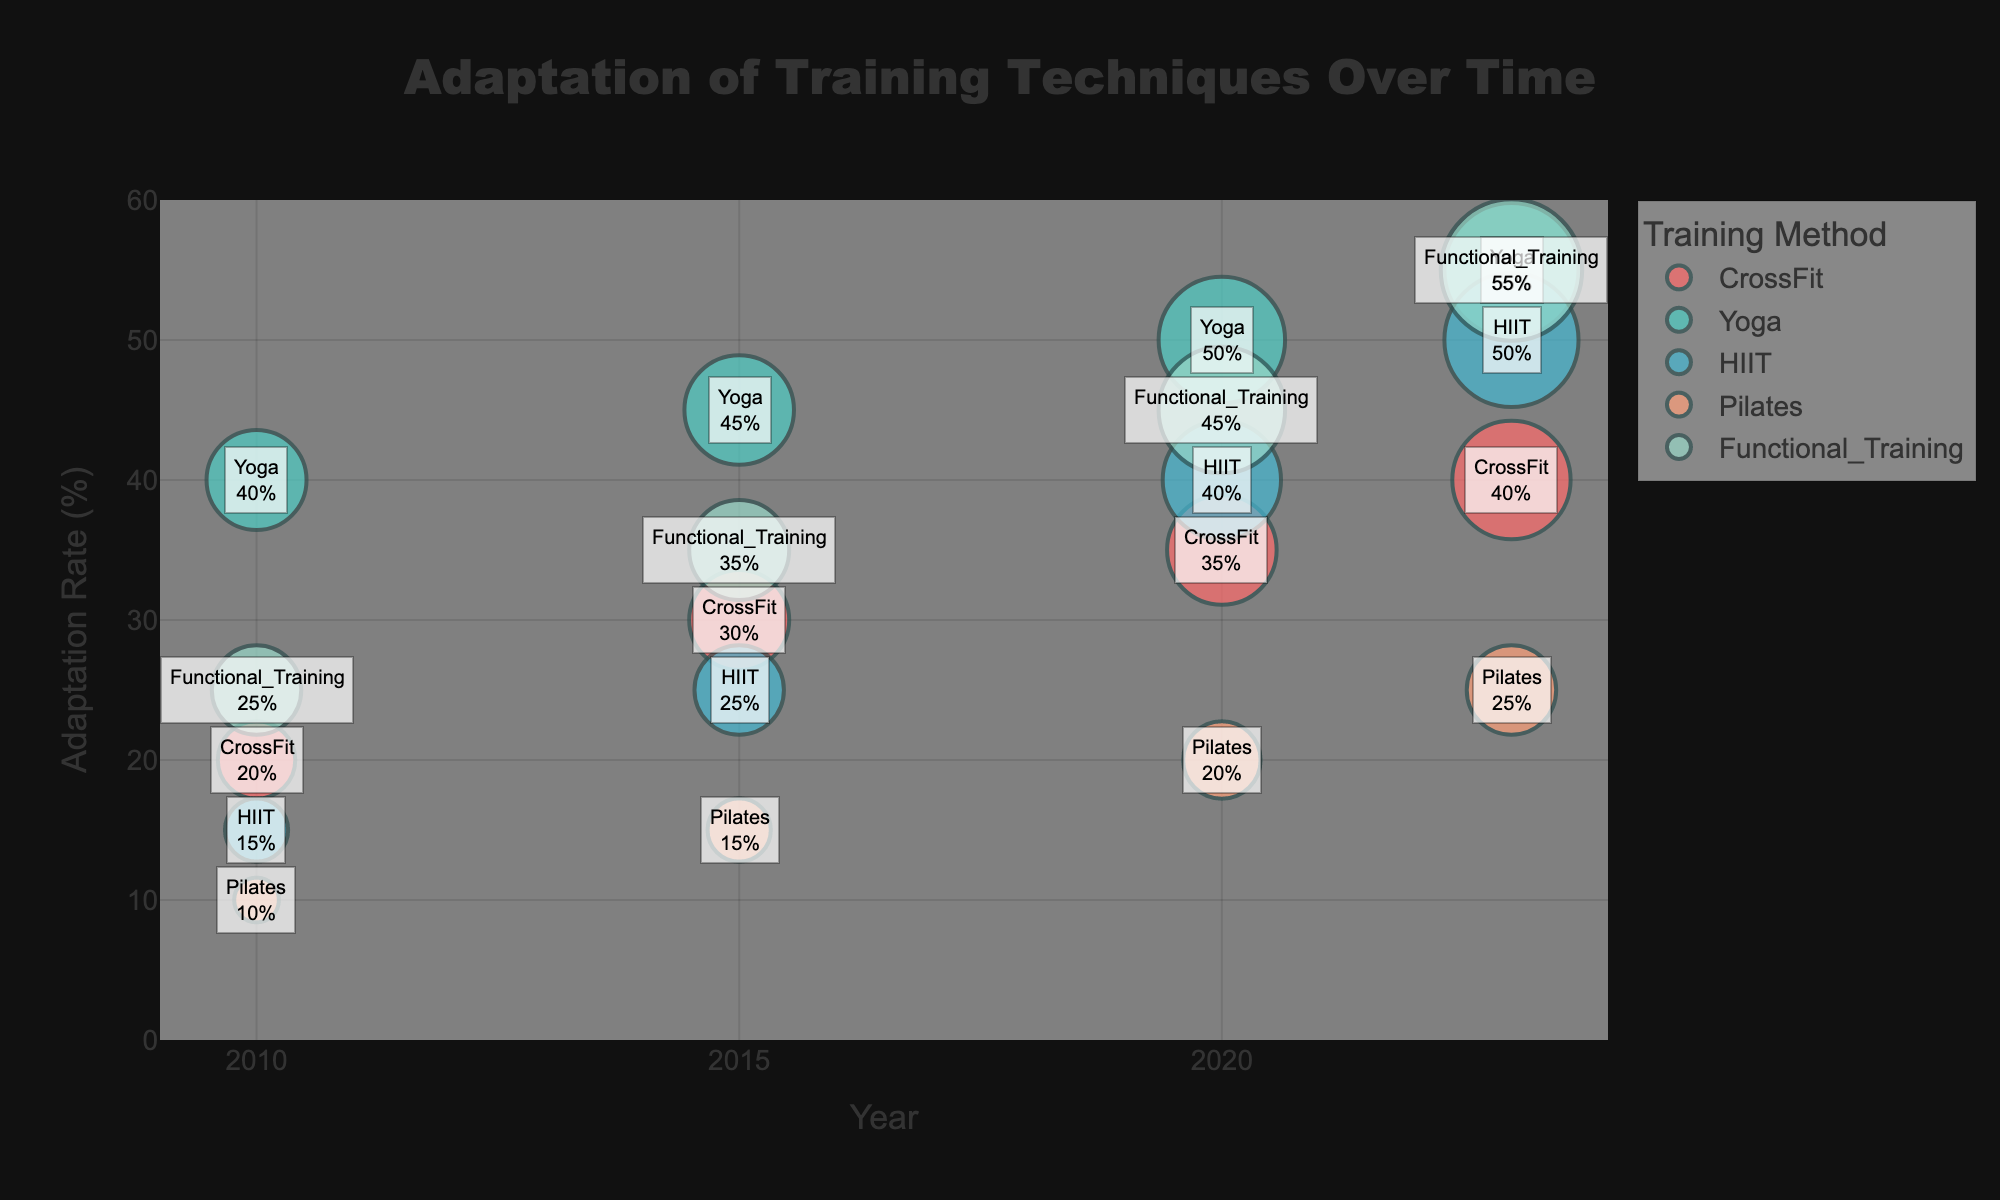What is the title of the graph? The graph's title is usually positioned at the top center and provides a clear indication of what the chart represents. Here, the title reads "Adaptation of Training Techniques Over Time".
Answer: Adaptation of Training Techniques Over Time In which year does CrossFit have the highest Adaptation Rate? To find this, look at the points marked for CrossFit across different years and identify the highest Adaptation Rate. The highest Adaptation Rate for CrossFit is in 2023, at 40%.
Answer: 2023 What are the axes representing? The x-axis is labeled 'Year', representing time progression, while the y-axis is labeled 'Adaptation Rate (%)', showing the percentage adaptation rate of training techniques.
Answer: Year, Adaptation Rate (%) Which training method shows the most significant increase in Adaptation Rate from 2010 to 2023? Calculate the difference in Adaptation Rate for each training method between 2023 and 2010. The training method Functional Training shows the most significant increase from 25% in 2010 to 55% in 2023, an increase of 30%.
Answer: Functional Training Comparing Yoga and HIIT, which method had a higher Adaptation Rate in 2015? By checking the Adaptation Rates for Yoga and HIIT in 2015, Yoga has a higher rate at 45% compared to HIIT’s 25%.
Answer: Yoga What is the size of the bubble representing HIIT in 2020? The size of the bubbles corresponds to the 'Trainer Use Popularity'. For HIIT in 2020, the bubble size is linked to a popularity of 35.
Answer: 35 How has the Adaptation Rate of Pilates changed from 2010 to 2023? Look at the Adaptation Rates for Pilates across these years. From 2010 to 2023, it changes from 10% to 25%.
Answer: Increased by 15% Which training method has the largest bubble in 2023? The size of the bubbles correlates with 'Trainer Use Popularity'. In 2023, the largest bubble, indicating the highest popularity, belongs to Functional Training with a popularity of 50.
Answer: Functional Training List the Adaptation Rates of Yoga in all the years shown. Read the y-values for Yoga across all the years: in 2010 (40%), 2015 (45%), 2020 (50%), and 2023 (55%).
Answer: 40%, 45%, 50%, 55% For which year are the Adaptation Rates of HIIT and Functional Training equal? Compare the Adaptation Rates of HIIT and Functional Training across the years. In 2023, both methods have an Adaptation Rate of 50%.
Answer: 2023 